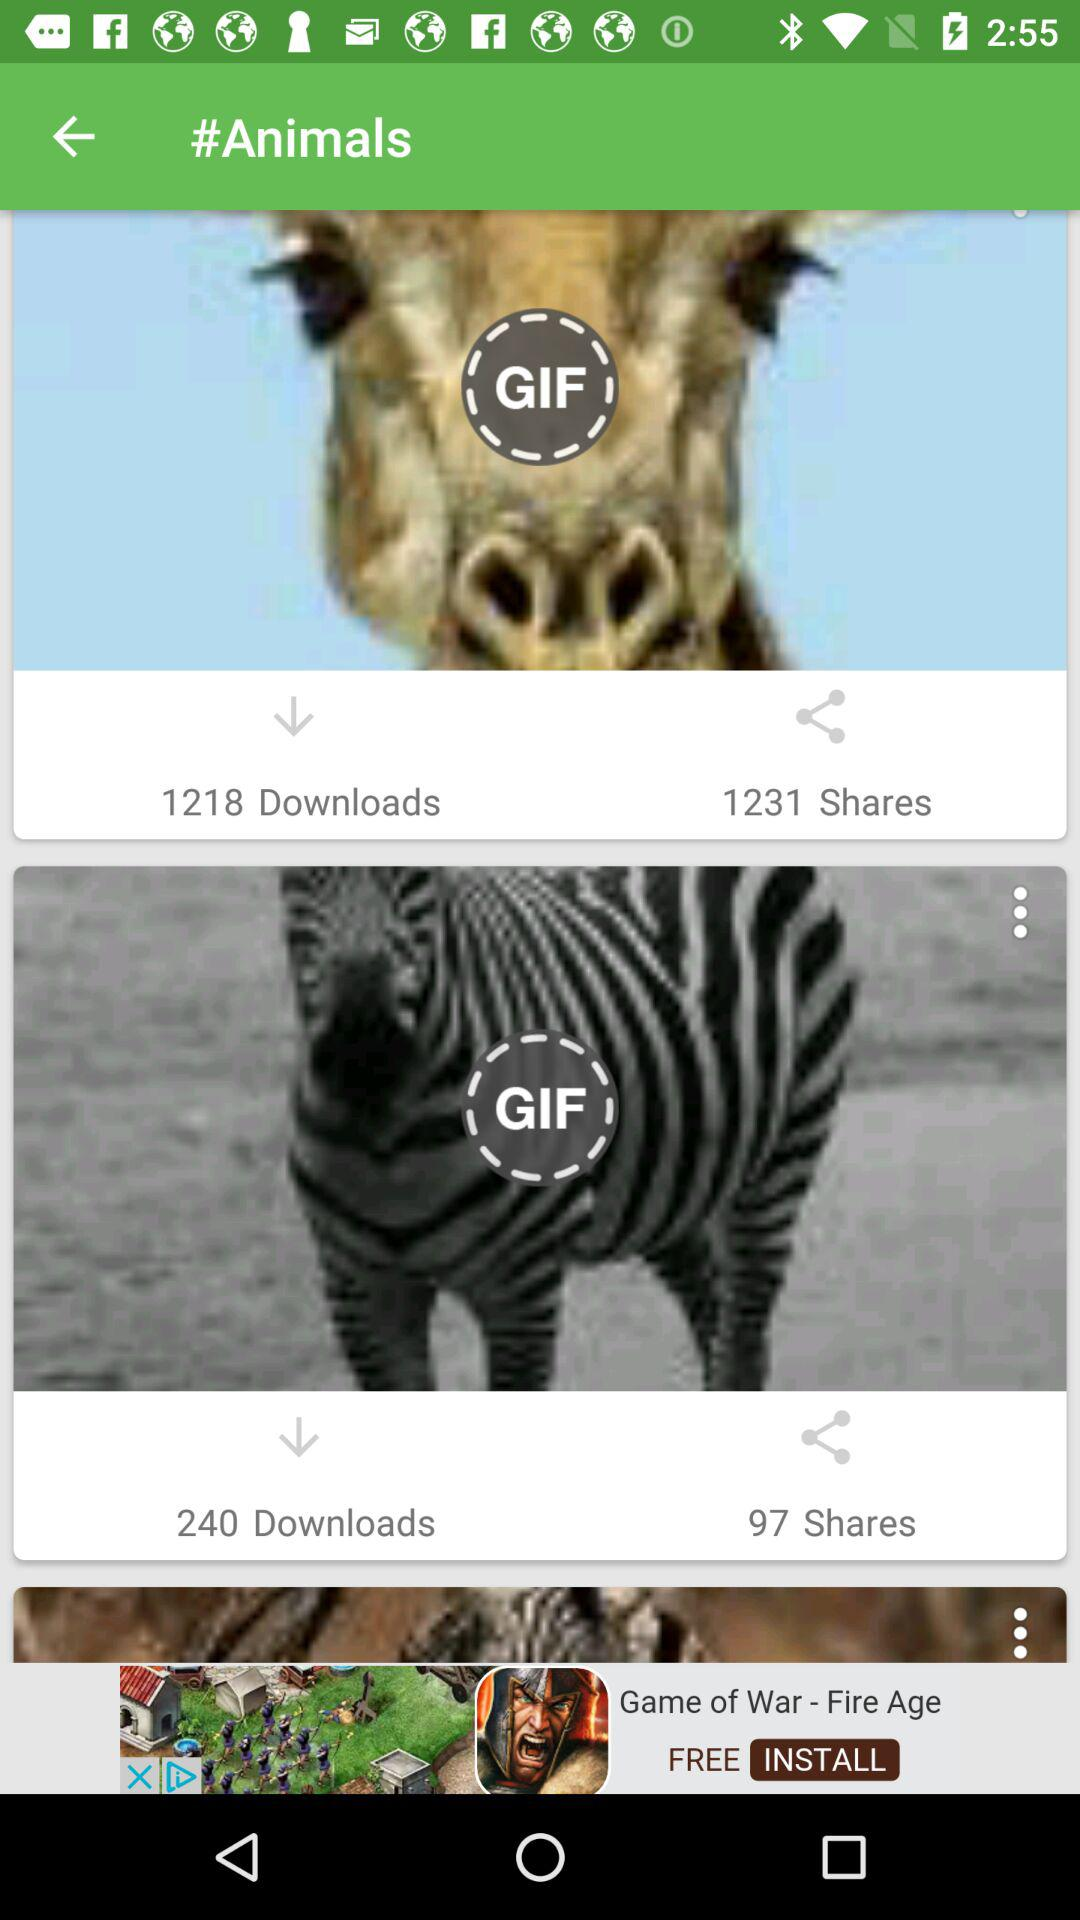Who got 1218 downloads?
When the provided information is insufficient, respond with <no answer>. <no answer> 